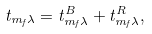Convert formula to latex. <formula><loc_0><loc_0><loc_500><loc_500>t _ { m _ { f } \lambda } = t _ { m _ { f } \lambda } ^ { B } + t _ { m _ { f } \lambda } ^ { R } ,</formula> 